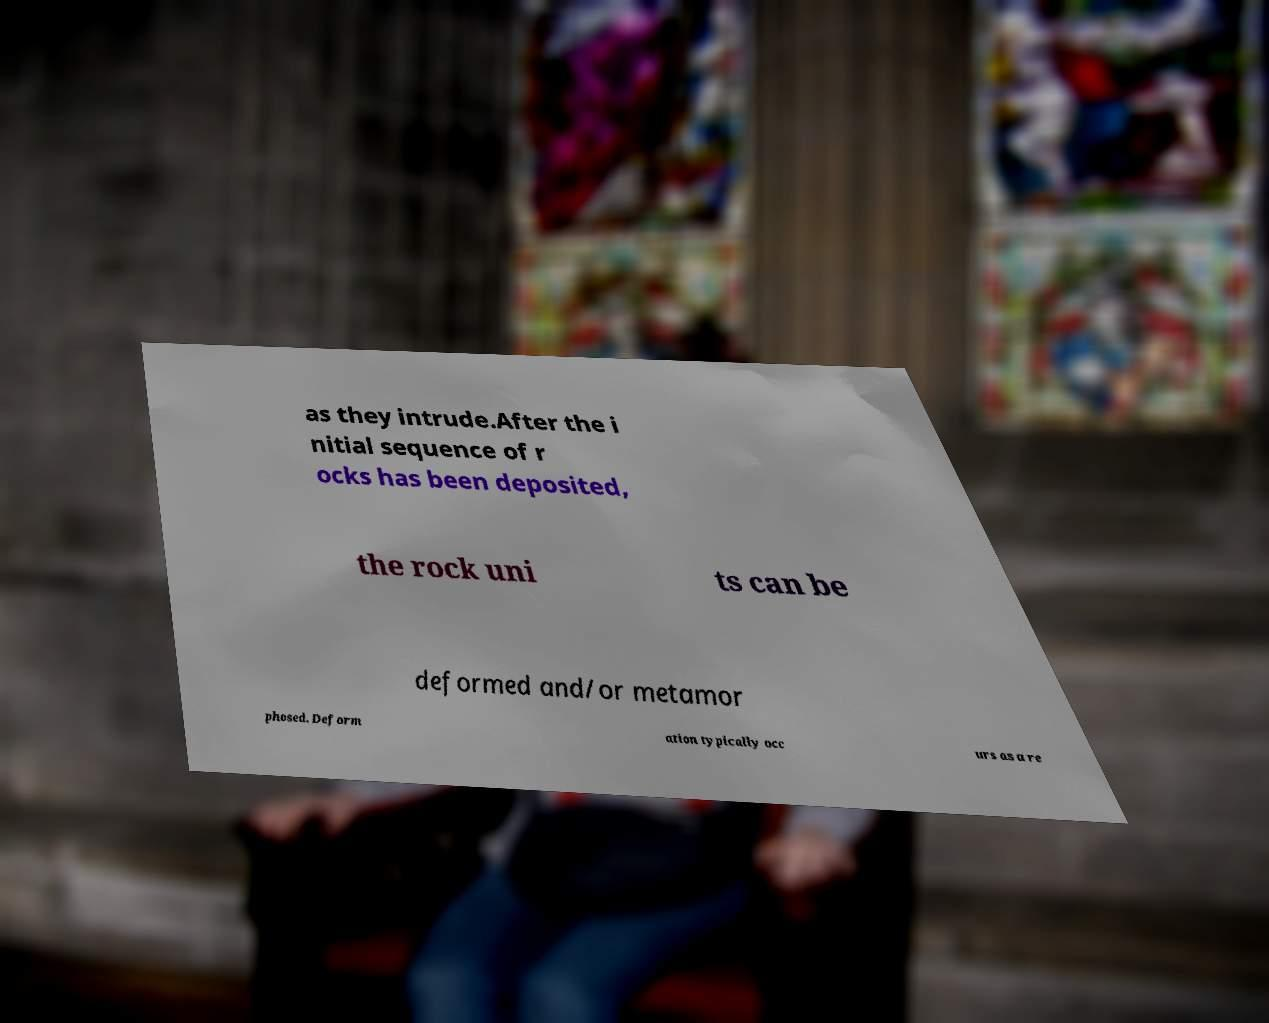Can you read and provide the text displayed in the image?This photo seems to have some interesting text. Can you extract and type it out for me? as they intrude.After the i nitial sequence of r ocks has been deposited, the rock uni ts can be deformed and/or metamor phosed. Deform ation typically occ urs as a re 